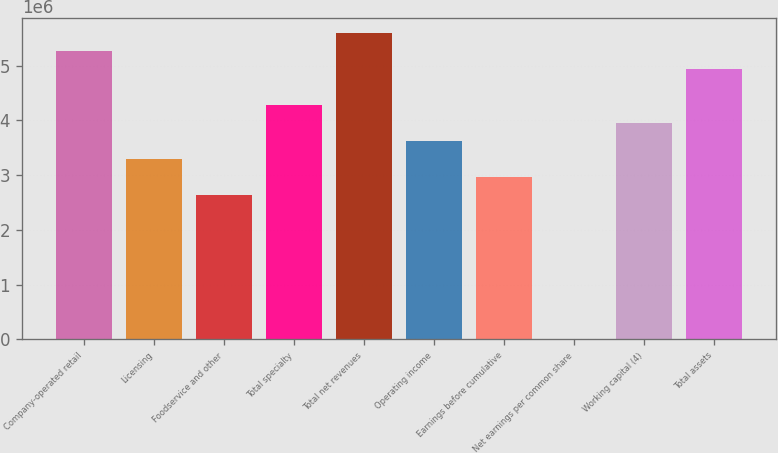Convert chart to OTSL. <chart><loc_0><loc_0><loc_500><loc_500><bar_chart><fcel>Company-operated retail<fcel>Licensing<fcel>Foodservice and other<fcel>Total specialty<fcel>Total net revenues<fcel>Operating income<fcel>Earnings before cumulative<fcel>Net earnings per common share<fcel>Working capital (4)<fcel>Total assets<nl><fcel>5.26225e+06<fcel>3.28891e+06<fcel>2.63113e+06<fcel>4.27558e+06<fcel>5.59114e+06<fcel>3.6178e+06<fcel>2.96002e+06<fcel>0.26<fcel>3.94669e+06<fcel>4.93336e+06<nl></chart> 